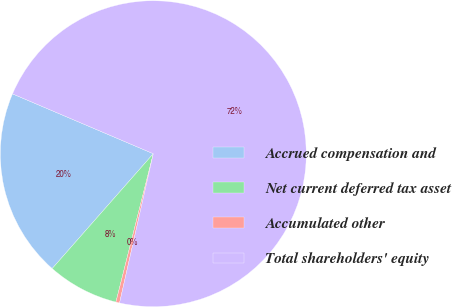Convert chart to OTSL. <chart><loc_0><loc_0><loc_500><loc_500><pie_chart><fcel>Accrued compensation and<fcel>Net current deferred tax asset<fcel>Accumulated other<fcel>Total shareholders' equity<nl><fcel>19.91%<fcel>7.56%<fcel>0.39%<fcel>72.14%<nl></chart> 